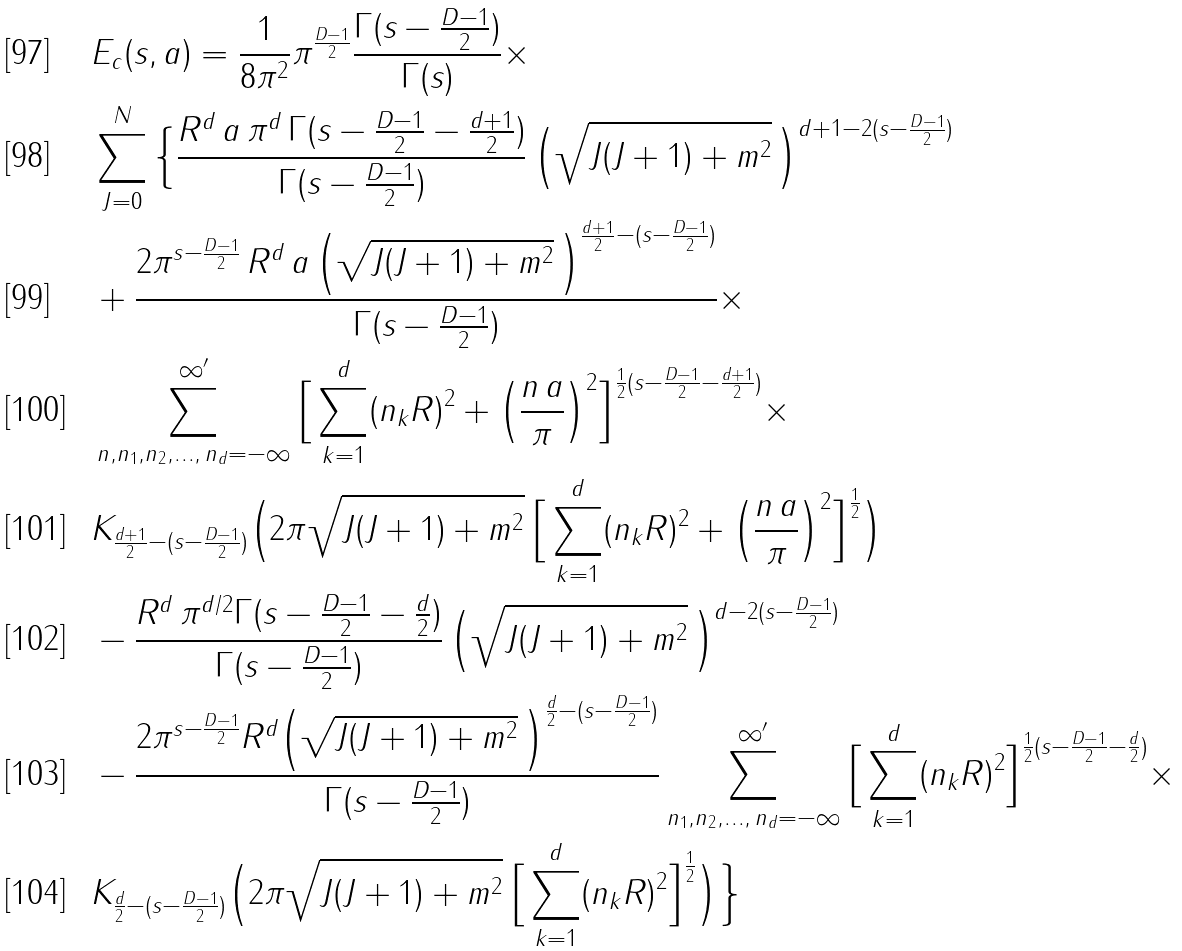<formula> <loc_0><loc_0><loc_500><loc_500>& E _ { c } ( s , a ) = \frac { 1 } { 8 \pi ^ { 2 } } \pi ^ { \frac { D - 1 } { 2 } } \frac { \Gamma ( s - \frac { D - 1 } { 2 } ) } { \Gamma ( s ) } \times \\ & \sum _ { J = 0 } ^ { N } \Big { \{ } \frac { R ^ { d } { \, } a { \, } \pi ^ { d } { \, } \Gamma ( s - \frac { D - 1 } { 2 } - \frac { d + 1 } { 2 } ) } { \Gamma ( s - \frac { D - 1 } { 2 } ) } { \, } \Big { ( } \sqrt { J ( J + 1 ) + m ^ { 2 } } { \, } \Big { ) } ^ { d + 1 - 2 ( s - \frac { D - 1 } { 2 } ) } \\ & + \frac { 2 \pi ^ { s - \frac { D - 1 } { 2 } } { \, } R ^ { d } { \, } a { \, } \Big { ( } \sqrt { J ( J + 1 ) + m ^ { 2 } } { \, } \Big { ) } ^ { \frac { d + 1 } { 2 } - ( s - \frac { D - 1 } { 2 } ) } } { \Gamma ( s - \frac { D - 1 } { 2 } ) } \times \\ & \sum ^ { \infty ^ { \prime } } _ { n , n _ { 1 } , n _ { 2 } , \dots , { \, } n _ { d } = - \infty } \Big { [ } \sum _ { k = 1 } ^ { d } ( n _ { k } R ) ^ { 2 } + \Big { ( } \frac { n { \, } a } { \pi } \Big { ) } ^ { 2 } \Big { ] } ^ { \frac { 1 } { 2 } ( s - \frac { D - 1 } { 2 } - \frac { d + 1 } { 2 } ) } \times \\ & K _ { \frac { d + 1 } { 2 } - ( s - \frac { D - 1 } { 2 } ) } \Big { ( } 2 \pi \sqrt { J ( J + 1 ) + m ^ { 2 } } { \, } \Big { [ } \sum _ { k = 1 } ^ { d } ( n _ { k } R ) ^ { 2 } + \Big { ( } \frac { n { \, } a } { \pi } \Big { ) } ^ { 2 } \Big { ] } ^ { \frac { 1 } { 2 } } \Big { ) } \\ & - \frac { R ^ { d } { \, } \pi ^ { d / 2 } \Gamma ( s - \frac { D - 1 } { 2 } - \frac { d } { 2 } ) } { \Gamma ( s - \frac { D - 1 } { 2 } ) } { \, } \Big { ( } \sqrt { J ( J + 1 ) + m ^ { 2 } } { \, } \Big { ) } ^ { d - 2 ( s - \frac { D - 1 } { 2 } ) } \\ & - \frac { 2 \pi ^ { s - \frac { D - 1 } { 2 } } R ^ { d } \Big { ( } \sqrt { J ( J + 1 ) + m ^ { 2 } } { \, } \Big { ) } ^ { \frac { d } { 2 } - ( s - \frac { D - 1 } { 2 } ) } } { \Gamma ( s - \frac { D - 1 } { 2 } ) } \sum ^ { \infty ^ { \prime } } _ { n _ { 1 } , n _ { 2 } , \dots , { \, } n _ { d } = - \infty } \Big { [ } \sum _ { k = 1 } ^ { d } ( n _ { k } R ) ^ { 2 } \Big { ] } ^ { \frac { 1 } { 2 } ( s - \frac { D - 1 } { 2 } - \frac { d } { 2 } ) } \times \\ & K _ { \frac { d } { 2 } - ( s - \frac { D - 1 } { 2 } ) } \Big { ( } 2 \pi \sqrt { J ( J + 1 ) + m ^ { 2 } } { \, } \Big { [ } \sum _ { k = 1 } ^ { d } ( n _ { k } R ) ^ { 2 } \Big { ] } ^ { \frac { 1 } { 2 } } \Big { ) } \Big { \} }</formula> 